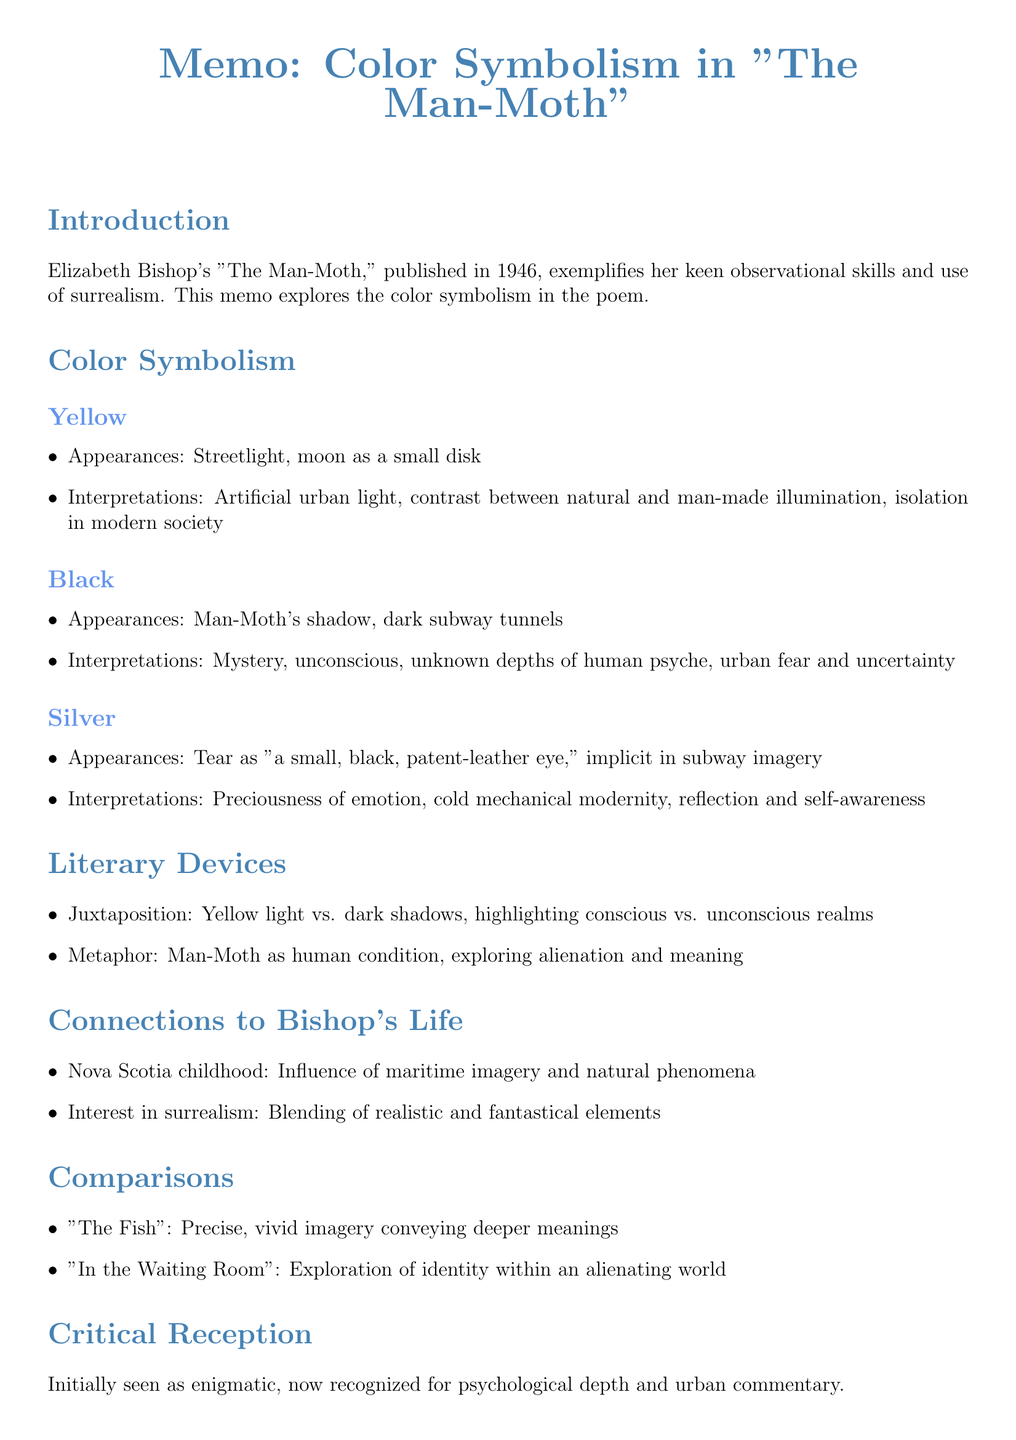What year was "The Man-Moth" published? The document states that the poem was published in 1946.
Answer: 1946 What color is associated with the streetlight in the poem? The document lists yellow as the color connected to the streetlight.
Answer: Yellow What literary device is used to contrast yellow light and dark shadows? The document mentions juxtaposition as the literary device highlighting this contrast.
Answer: Juxtaposition What is one interpretation of the color black in the poem? The document explains that black is interpreted as representing mystery and the unconscious.
Answer: Mystery Which childhood aspect influenced Bishop's imagery? The document states that her childhood in Nova Scotia influenced maritime imagery and natural phenomena.
Answer: Nova Scotia What poem is compared to "The Man-Moth" for its vivid imagery? The document includes "The Fish" as a poem that uses precise, vivid imagery.
Answer: The Fish What is a contemporary view of "The Man-Moth"? The document notes that it was initially seen as enigmatic and challenging.
Answer: Enigmatic What aspect of Bishop's life relates to her interest in surrealism? The document relates her interest in surrealism to blending realistic and fantastical elements in the poem.
Answer: Surrealism What color represents the preciousness of genuine emotion in the poem? The document indicates that silver is associated with the preciousness of genuine emotion.
Answer: Silver 